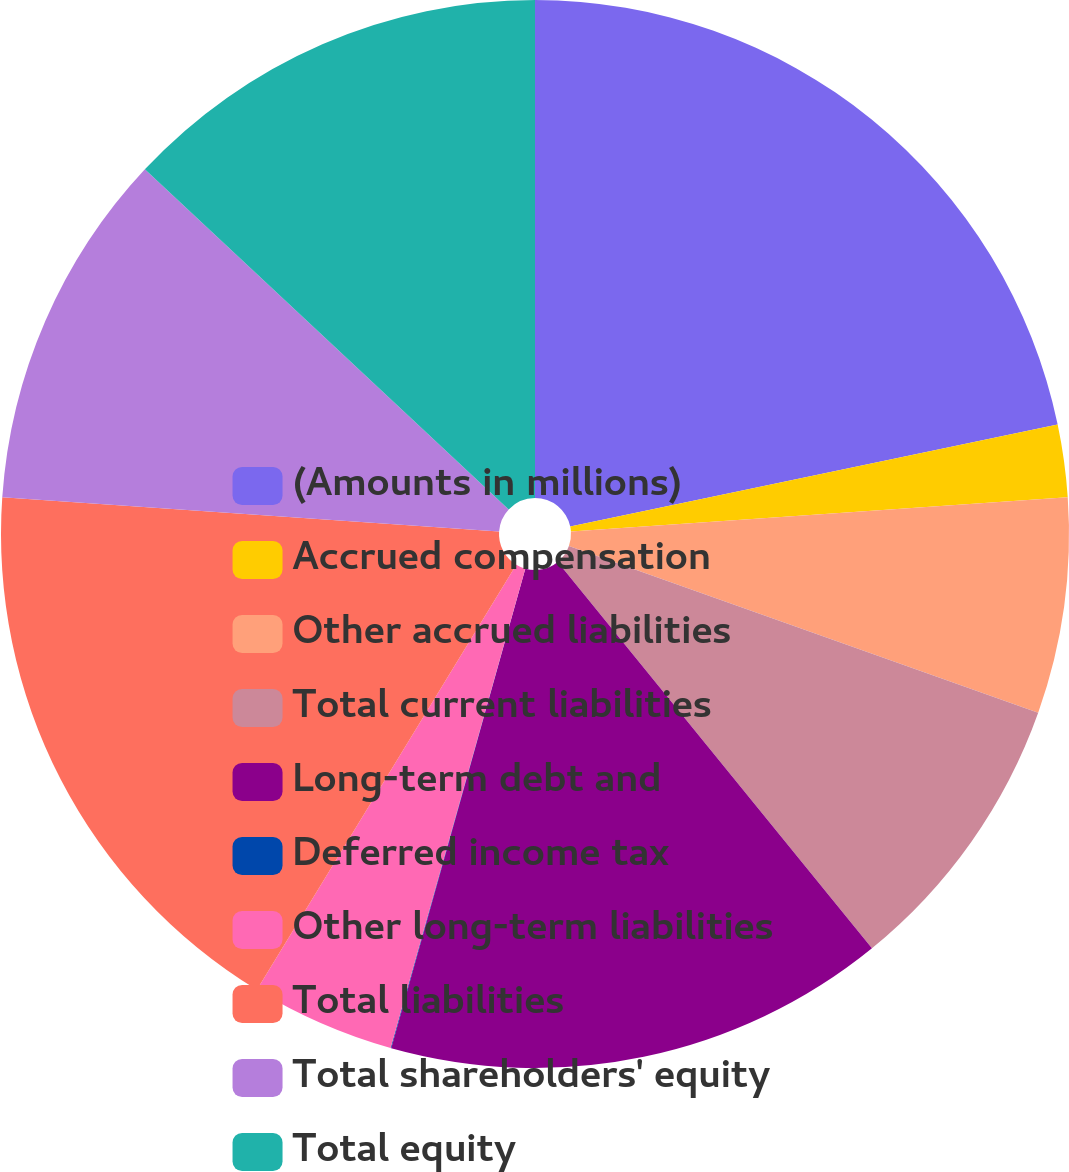Convert chart to OTSL. <chart><loc_0><loc_0><loc_500><loc_500><pie_chart><fcel>(Amounts in millions)<fcel>Accrued compensation<fcel>Other accrued liabilities<fcel>Total current liabilities<fcel>Long-term debt and<fcel>Deferred income tax<fcel>Other long-term liabilities<fcel>Total liabilities<fcel>Total shareholders' equity<fcel>Total equity<nl><fcel>21.72%<fcel>2.19%<fcel>6.53%<fcel>8.7%<fcel>15.21%<fcel>0.02%<fcel>4.36%<fcel>17.38%<fcel>10.87%<fcel>13.04%<nl></chart> 